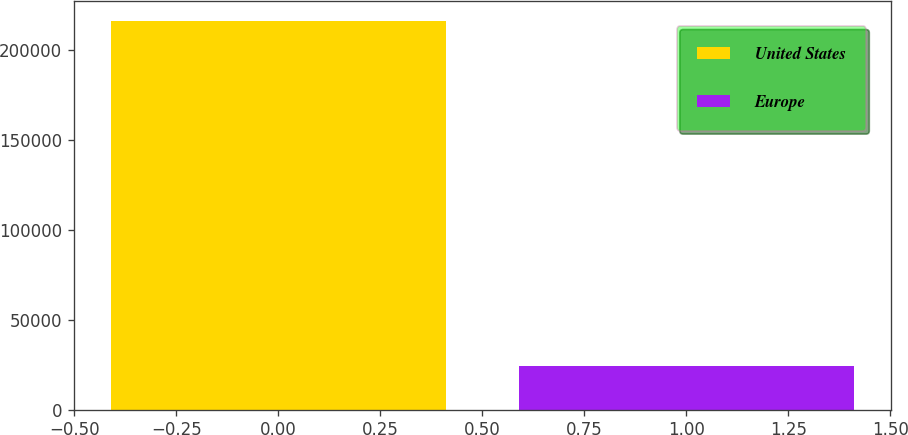Convert chart to OTSL. <chart><loc_0><loc_0><loc_500><loc_500><bar_chart><fcel>United States<fcel>Europe<nl><fcel>216138<fcel>23986<nl></chart> 